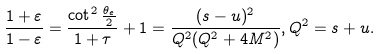Convert formula to latex. <formula><loc_0><loc_0><loc_500><loc_500>\frac { 1 + \varepsilon } { 1 - \varepsilon } = \frac { \cot ^ { 2 } \frac { \theta _ { e } } { 2 } } { 1 + \tau } + 1 = \frac { ( s - u ) ^ { 2 } } { Q ^ { 2 } ( Q ^ { 2 } + 4 M ^ { 2 } ) } , Q ^ { 2 } = s + u .</formula> 